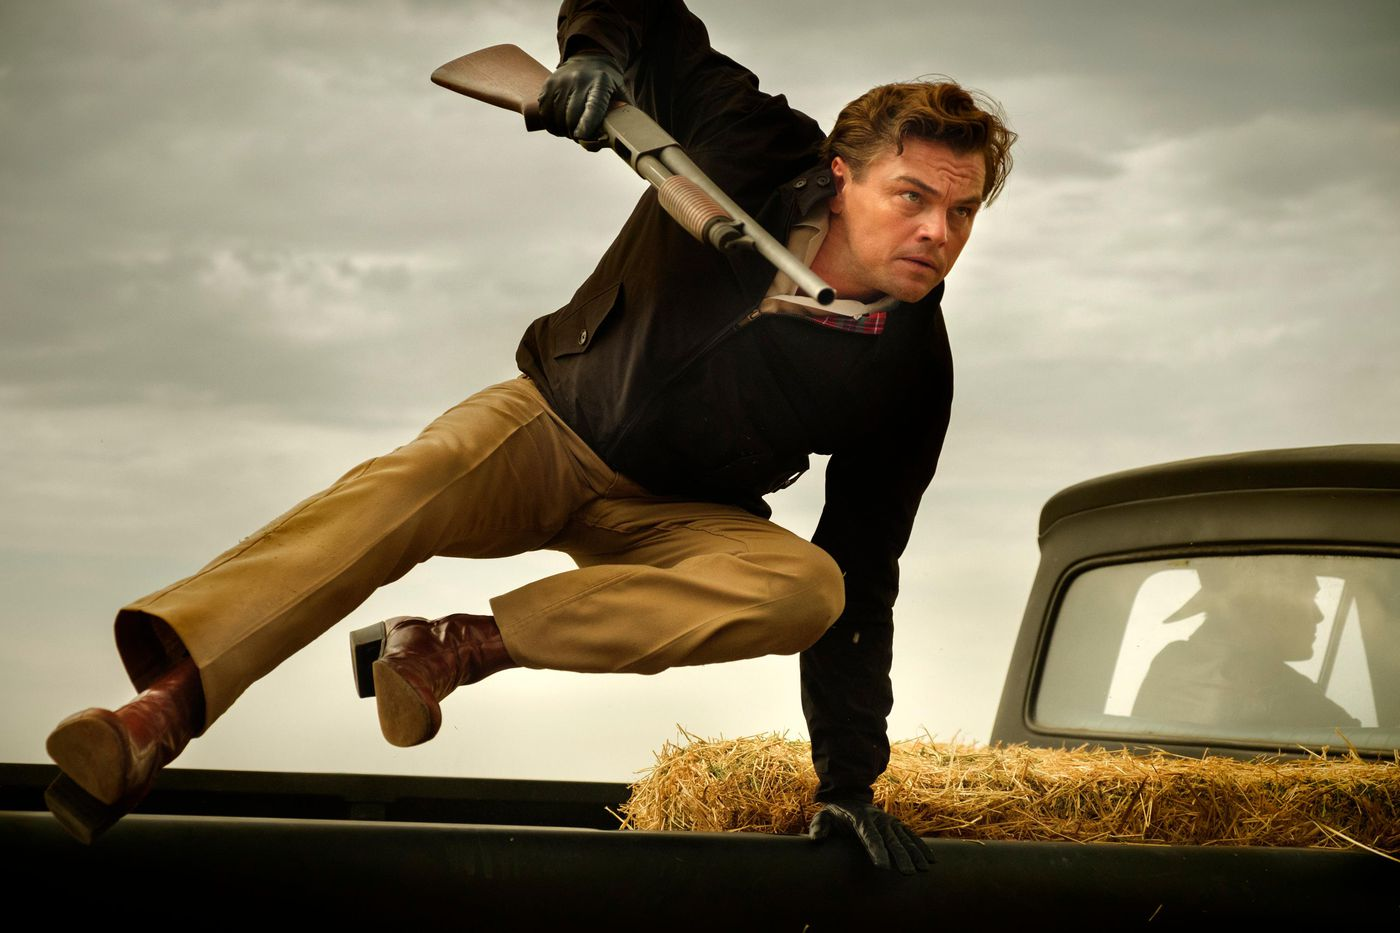Describe in vivid detail the expression on the man's face. The man’s face is a portrait of steely determination and focus. His brows are furrowed, and his eyes, intense and unwavering, are fixed on something ahead. His lips are pressed into a thin, tight line, adding to the expression of resolve and urgency. This intense look suggests that he is fully immersed in the moment, with every muscle in his face contributing to his laser-sharp concentration as he makes a bold move over the car. 